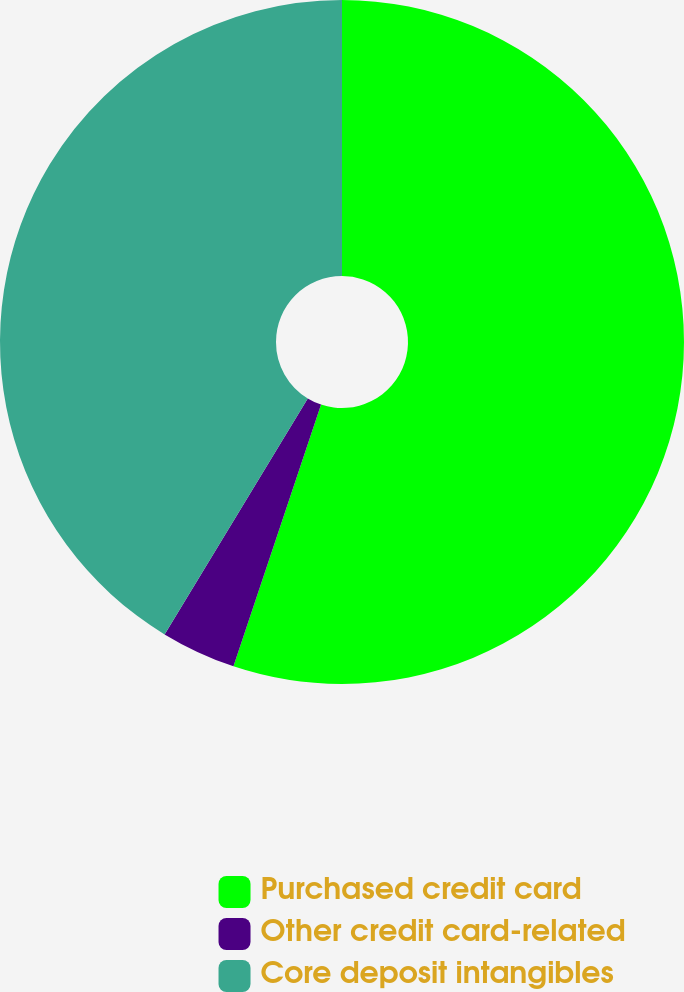Convert chart. <chart><loc_0><loc_0><loc_500><loc_500><pie_chart><fcel>Purchased credit card<fcel>Other credit card-related<fcel>Core deposit intangibles<nl><fcel>55.14%<fcel>3.54%<fcel>41.32%<nl></chart> 